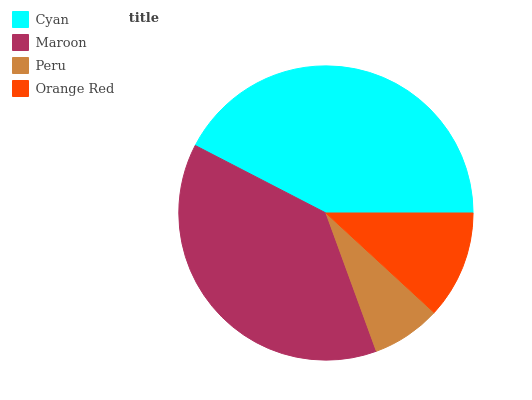Is Peru the minimum?
Answer yes or no. Yes. Is Cyan the maximum?
Answer yes or no. Yes. Is Maroon the minimum?
Answer yes or no. No. Is Maroon the maximum?
Answer yes or no. No. Is Cyan greater than Maroon?
Answer yes or no. Yes. Is Maroon less than Cyan?
Answer yes or no. Yes. Is Maroon greater than Cyan?
Answer yes or no. No. Is Cyan less than Maroon?
Answer yes or no. No. Is Maroon the high median?
Answer yes or no. Yes. Is Orange Red the low median?
Answer yes or no. Yes. Is Orange Red the high median?
Answer yes or no. No. Is Peru the low median?
Answer yes or no. No. 